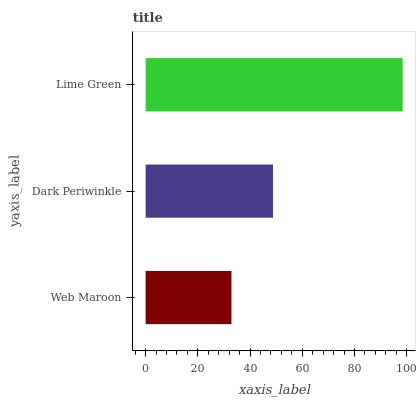Is Web Maroon the minimum?
Answer yes or no. Yes. Is Lime Green the maximum?
Answer yes or no. Yes. Is Dark Periwinkle the minimum?
Answer yes or no. No. Is Dark Periwinkle the maximum?
Answer yes or no. No. Is Dark Periwinkle greater than Web Maroon?
Answer yes or no. Yes. Is Web Maroon less than Dark Periwinkle?
Answer yes or no. Yes. Is Web Maroon greater than Dark Periwinkle?
Answer yes or no. No. Is Dark Periwinkle less than Web Maroon?
Answer yes or no. No. Is Dark Periwinkle the high median?
Answer yes or no. Yes. Is Dark Periwinkle the low median?
Answer yes or no. Yes. Is Web Maroon the high median?
Answer yes or no. No. Is Web Maroon the low median?
Answer yes or no. No. 